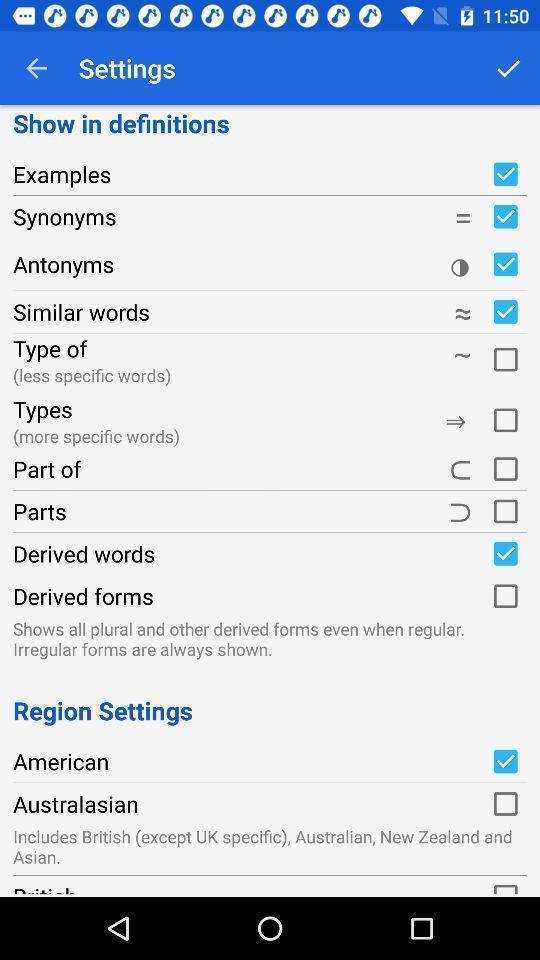Please provide a description for this image. Screen showing settings page. 